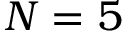<formula> <loc_0><loc_0><loc_500><loc_500>N = 5</formula> 